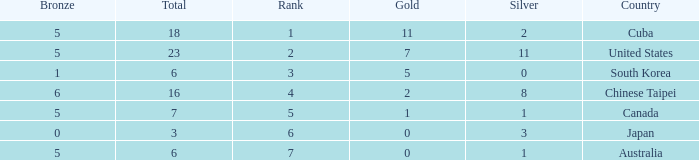What was the sum of the ranks for Japan who had less than 5 bronze medals and more than 3 silvers? None. 